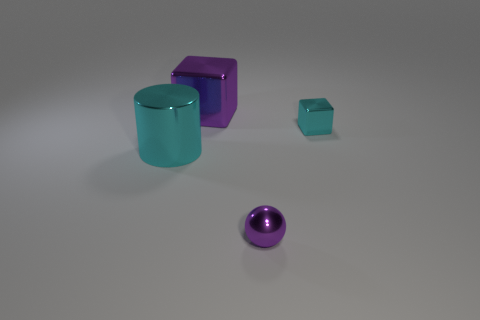What number of brown objects are either shiny objects or metal cubes?
Give a very brief answer. 0. Does the purple metallic object that is to the left of the small purple shiny sphere have the same shape as the large metal thing that is in front of the tiny metallic block?
Provide a short and direct response. No. What number of other objects are the same material as the big purple cube?
Ensure brevity in your answer.  3. There is a big metal object in front of the cyan thing on the right side of the large shiny cube; are there any small metallic blocks left of it?
Provide a succinct answer. No. Are the large cyan object and the purple ball made of the same material?
Keep it short and to the point. Yes. Are there any other things that are the same shape as the tiny cyan object?
Provide a succinct answer. Yes. There is a tiny object that is in front of the cyan thing that is to the right of the large metal cylinder; what is it made of?
Offer a very short reply. Metal. What size is the purple object that is right of the big purple shiny block?
Your answer should be very brief. Small. What color is the metal thing that is in front of the cyan metallic cube and behind the tiny purple ball?
Ensure brevity in your answer.  Cyan. Do the cyan thing that is to the right of the cylinder and the purple metallic cube have the same size?
Provide a short and direct response. No. 